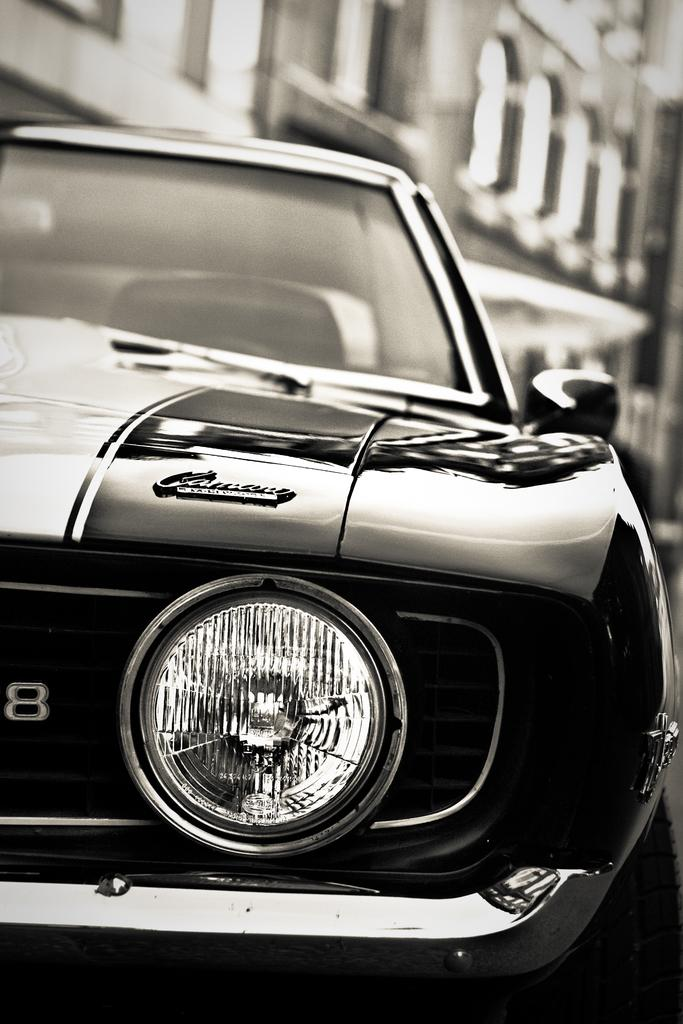What is the color scheme of the image? The image is black and white. What can be seen on the road in the image? There is a car on the road in the image. How would you describe the background of the image? The background of the image is blurred. What type of structure is visible in the background of the image? There is a building visible in the background of the image. What else can be seen in the background of the image? There are objects present in the background of the image. What type of quilt is being used to crush the car in the image? There is no quilt or crushing action present in the image; it features a car on the road with a blurred background. 